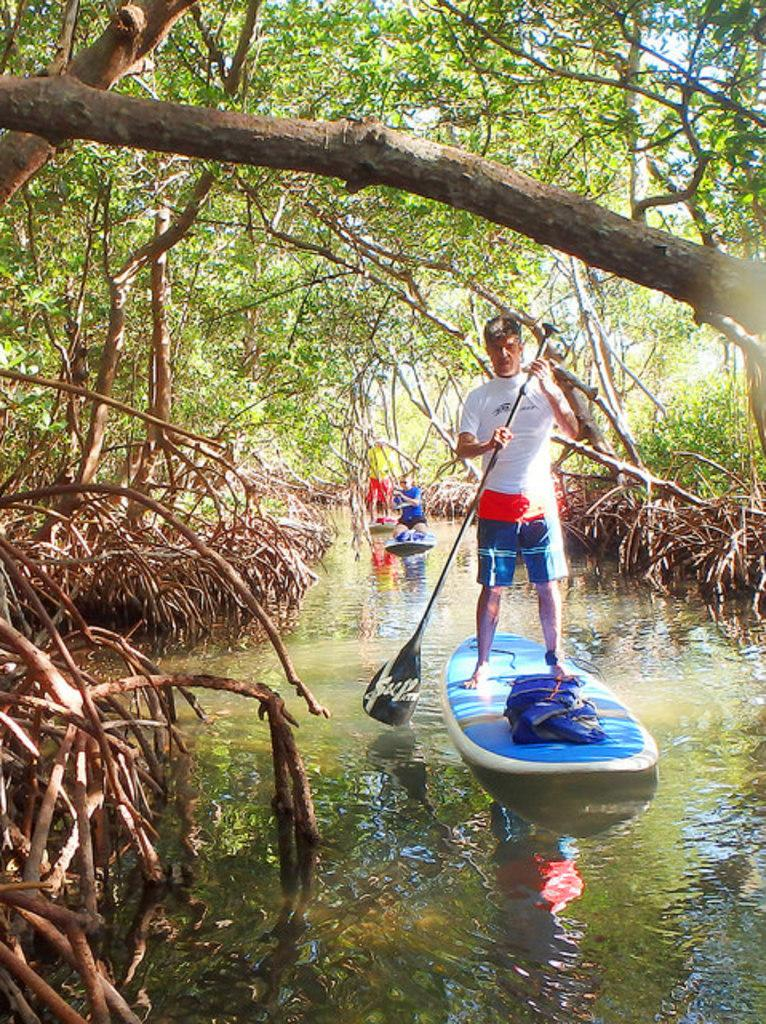What are the people in the image doing? The people in the image are doing boating in the water. What can be seen in the background of the image? There are trees visible in the image. What type of ink is being used by the farmer in the image? There is no farmer or ink present in the image; it features people boating in the water with trees in the background. 